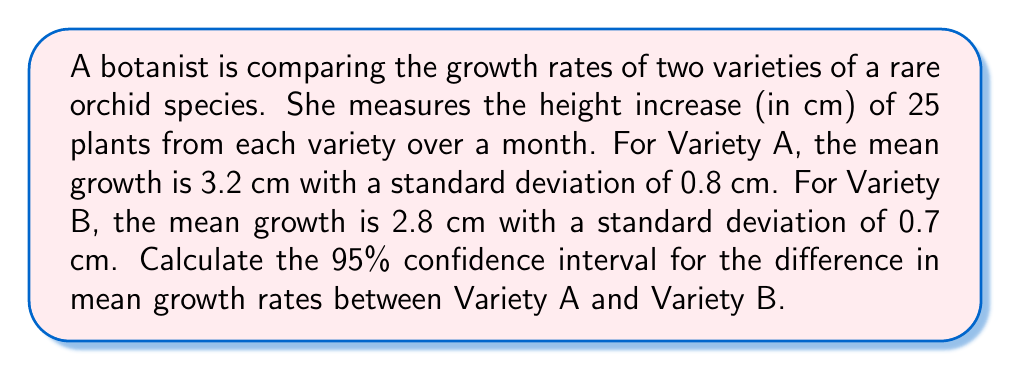Teach me how to tackle this problem. Let's approach this step-by-step:

1) We're dealing with the difference between two independent means, so we'll use the formula:

   $$((\bar{X}_1 - \bar{X}_2) \pm t_{\alpha/2} \sqrt{\frac{s_1^2}{n_1} + \frac{s_2^2}{n_2}})$$

   Where:
   $\bar{X}_1$ and $\bar{X}_2$ are the sample means
   $s_1$ and $s_2$ are the sample standard deviations
   $n_1$ and $n_2$ are the sample sizes
   $t_{\alpha/2}$ is the t-value for a 95% confidence interval with (n1 + n2 - 2) degrees of freedom

2) We have:
   $\bar{X}_1 = 3.2$, $\bar{X}_2 = 2.8$
   $s_1 = 0.8$, $s_2 = 0.7$
   $n_1 = n_2 = 25$

3) For a 95% CI with 48 degrees of freedom (25 + 25 - 2), $t_{\alpha/2} \approx 2.011$

4) Let's calculate the standard error:

   $$SE = \sqrt{\frac{s_1^2}{n_1} + \frac{s_2^2}{n_2}} = \sqrt{\frac{0.8^2}{25} + \frac{0.7^2}{25}} = \sqrt{0.0256 + 0.0196} = 0.2121$$

5) Now we can calculate the confidence interval:

   $$(3.2 - 2.8) \pm 2.011 * 0.2121$$
   $$0.4 \pm 0.4265$$

6) Therefore, the 95% CI is:

   $$(0.4 - 0.4265, 0.4 + 0.4265) = (-0.0265, 0.8265)$$
Answer: (-0.0265 cm, 0.8265 cm) 